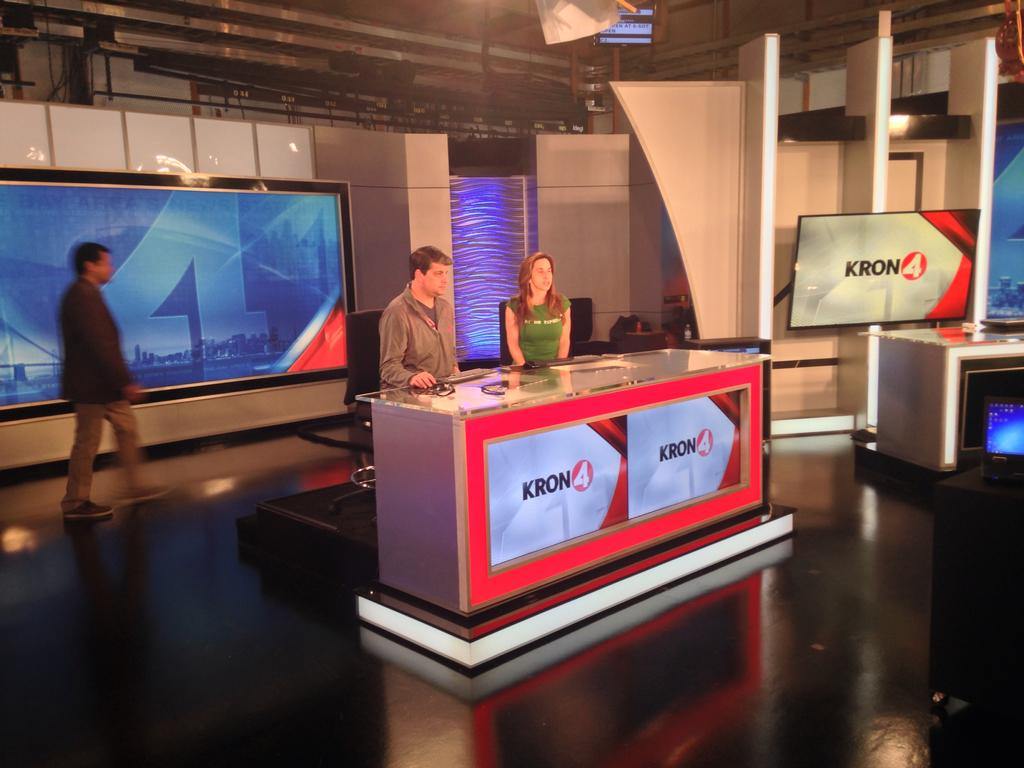Provide a one-sentence caption for the provided image. Two news reporters sit behind their Kron4 newsdesk as a man walks past behind them. 